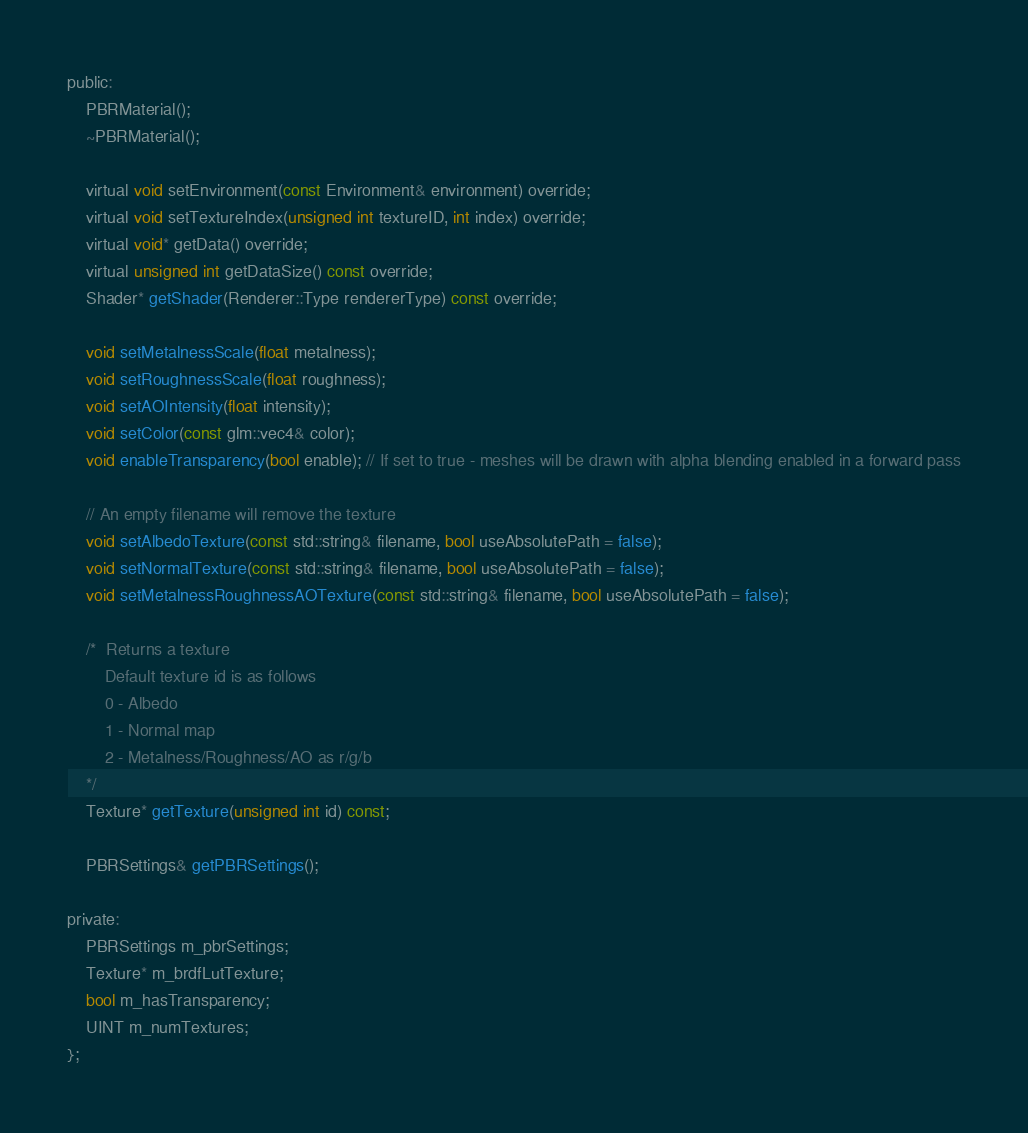Convert code to text. <code><loc_0><loc_0><loc_500><loc_500><_C_>
public:
	PBRMaterial();
	~PBRMaterial();

	virtual void setEnvironment(const Environment& environment) override;
	virtual void setTextureIndex(unsigned int textureID, int index) override;
	virtual void* getData() override;
	virtual unsigned int getDataSize() const override;
	Shader* getShader(Renderer::Type rendererType) const override;

	void setMetalnessScale(float metalness);
	void setRoughnessScale(float roughness);
	void setAOIntensity(float intensity);
	void setColor(const glm::vec4& color);
	void enableTransparency(bool enable); // If set to true - meshes will be drawn with alpha blending enabled in a forward pass

	// An empty filename will remove the texture
	void setAlbedoTexture(const std::string& filename, bool useAbsolutePath = false);
	void setNormalTexture(const std::string& filename, bool useAbsolutePath = false);
	void setMetalnessRoughnessAOTexture(const std::string& filename, bool useAbsolutePath = false);

	/*	Returns a texture
		Default texture id is as follows
		0 - Albedo
		1 - Normal map
		2 - Metalness/Roughness/AO as r/g/b
	*/
	Texture* getTexture(unsigned int id) const;

	PBRSettings& getPBRSettings();

private:
	PBRSettings m_pbrSettings;
	Texture* m_brdfLutTexture;
	bool m_hasTransparency;	
	UINT m_numTextures;
};</code> 